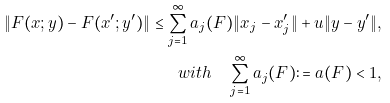<formula> <loc_0><loc_0><loc_500><loc_500>\left \| F ( x ; y ) - F ( x ^ { \prime } ; y ^ { \prime } ) \right \| \leq \sum _ { j = 1 } ^ { \infty } a _ { j } ( F ) \| x _ { j } - x ^ { \prime } _ { j } \| + u \| y - y ^ { \prime } \| , \\ w i t h \quad \sum _ { j = 1 } ^ { \infty } a _ { j } ( F ) \colon = a ( F ) < 1 ,</formula> 